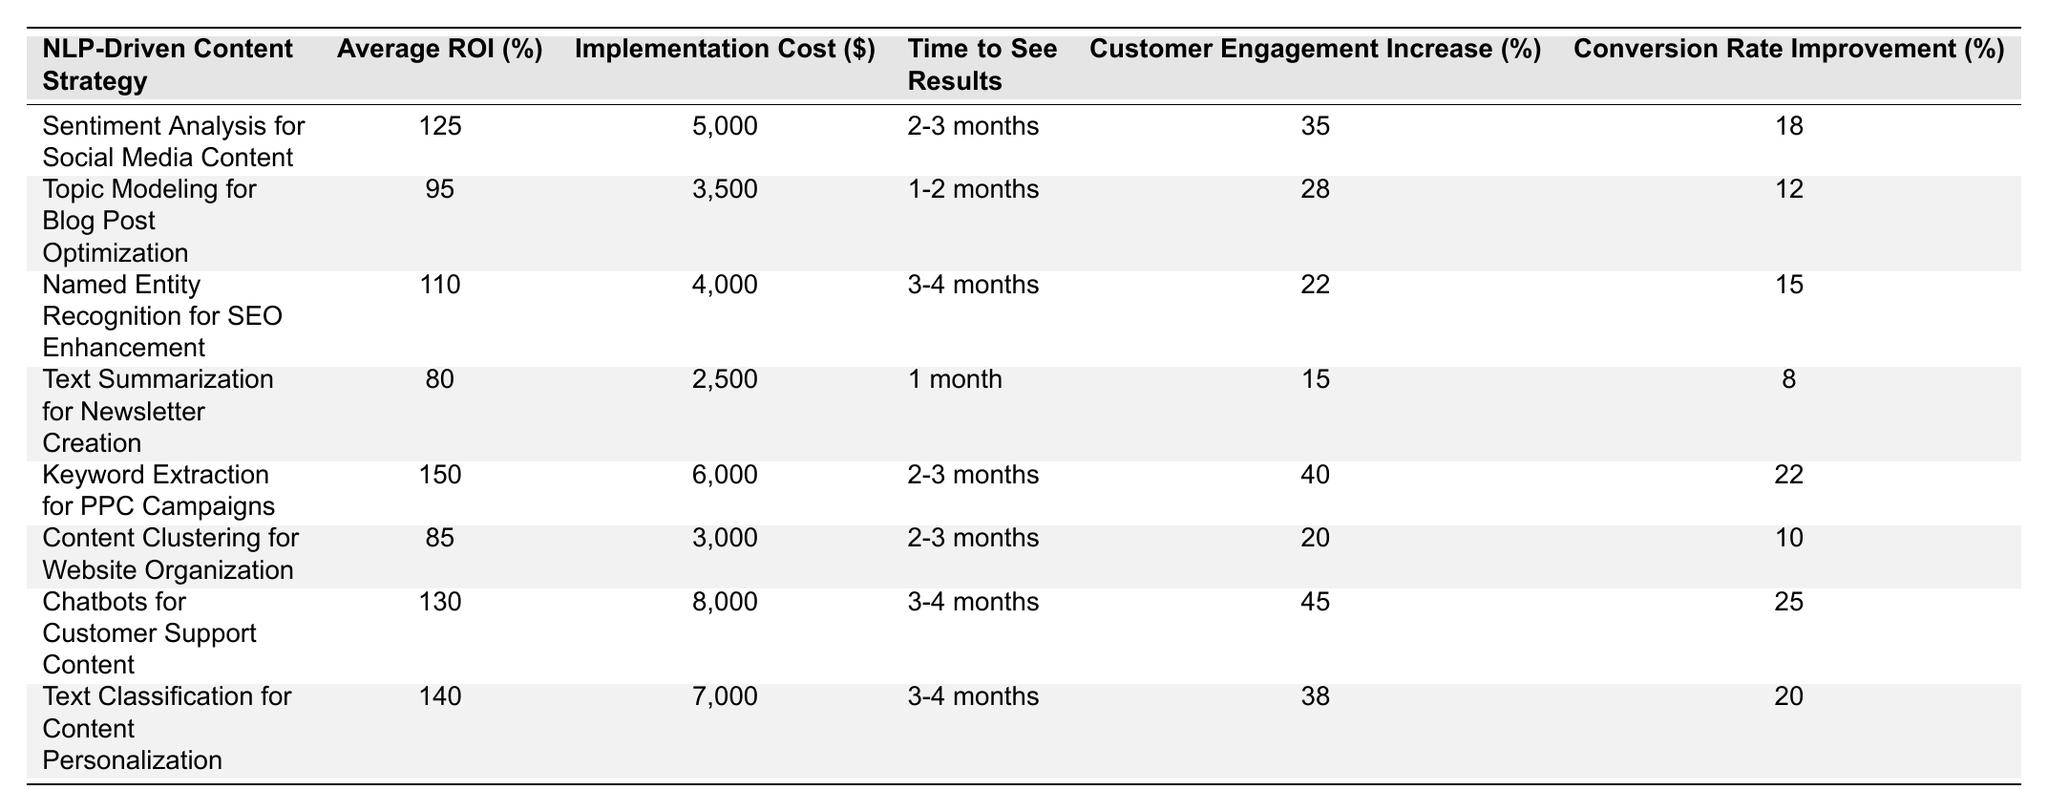What is the highest average ROI in the table? The table lists the average ROI for various NLP-driven content strategies. By scanning the "Average ROI (%)" column, we can see that "Keyword Extraction for PPC Campaigns" has the highest ROI at 150%.
Answer: 150% Which content strategy takes the shortest time to see results? By examining the "Time to See Results" column, we see that "Text Summarization for Newsletter Creation" reports the shortest time at "1 month".
Answer: 1 month How much more is the implementation cost for "Chatbots for Customer Support Content" compared to "Text Summarization for Newsletter Creation"? The implementation cost for "Chatbots for Customer Support Content" is $8,000, and for "Text Summarization for Newsletter Creation," it is $2,500. The difference is $8,000 - $2,500 = $5,500.
Answer: $5,500 Is the customer engagement increase for "Named Entity Recognition for SEO Enhancement" greater than 20%? The engagement increase for "Named Entity Recognition for SEO Enhancement" is 22%, which is greater than 20%. Therefore, the answer is Yes.
Answer: Yes What is the average customer engagement increase for the strategies listed? To find the average, we add the engagement increases (35 + 28 + 22 + 15 + 40 + 20 + 45 + 38) = 303 and divide by the number of strategies (8). The average is 303 / 8 = 37.875.
Answer: 37.875 Which strategy has the lowest conversion rate improvement? Checking the "Conversion Rate Improvement (%)" column, "Text Summarization for Newsletter Creation" shows the lowest conversion rate improvement at 8%.
Answer: 8% If you select the top three strategies by average ROI, what would be their average implementation cost? The top three strategies by average ROI are "Keyword Extraction for PPC Campaigns" (6000), "Chatbots for Customer Support Content" (8000), and "Text Classification for Content Personalization" (7000). The total implementation cost is $6,000 + $8,000 + $7,000 = $21,000. The average cost is $21,000 / 3 = $7,000.
Answer: $7,000 Which strategy improves conversion rates more than 20% and also has a cost less than $6,000? By inspecting the values, the strategy "Keyword Extraction for PPC Campaigns" has a conversion rate improvement of 22% but costs $6,000. "Content Clustering for Website Organization" has a conversion rate improvement of 10% with a cost of $3,000, which does not meet the conversion threshold. The only strategy that meets the criteria is "Text Classification for Content Personalization" with 20% improvement, but it costs $7,000, so none meet both criteria.
Answer: No What is the total average ROI for strategies that require 3-4 months to see results? For this, we identify the strategies that take 3-4 months: "Named Entity Recognition for SEO Enhancement" (110%), "Chatbots for Customer Support Content" (130%), and "Text Classification for Content Personalization" (140%). The total ROI is 110 + 130 + 140 = 380. The average is 380 / 3 = 126.67.
Answer: 126.67 